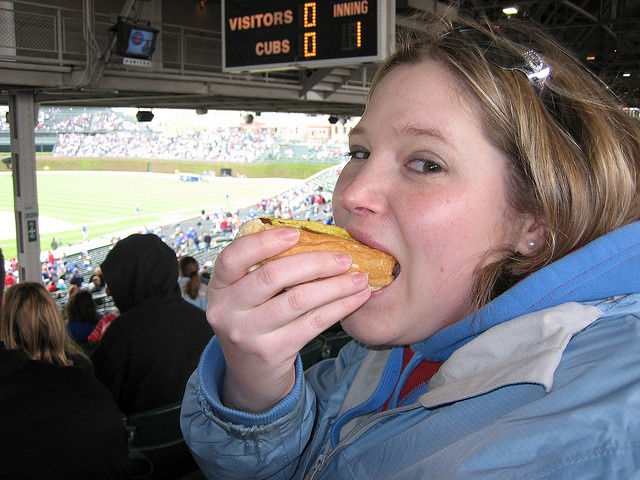Describe the objects in this image and their specific colors. I can see people in black, lightpink, gray, and darkgray tones, people in black and gray tones, people in black, maroon, and gray tones, people in black, lightgray, darkgray, and beige tones, and hot dog in black, tan, khaki, and brown tones in this image. 